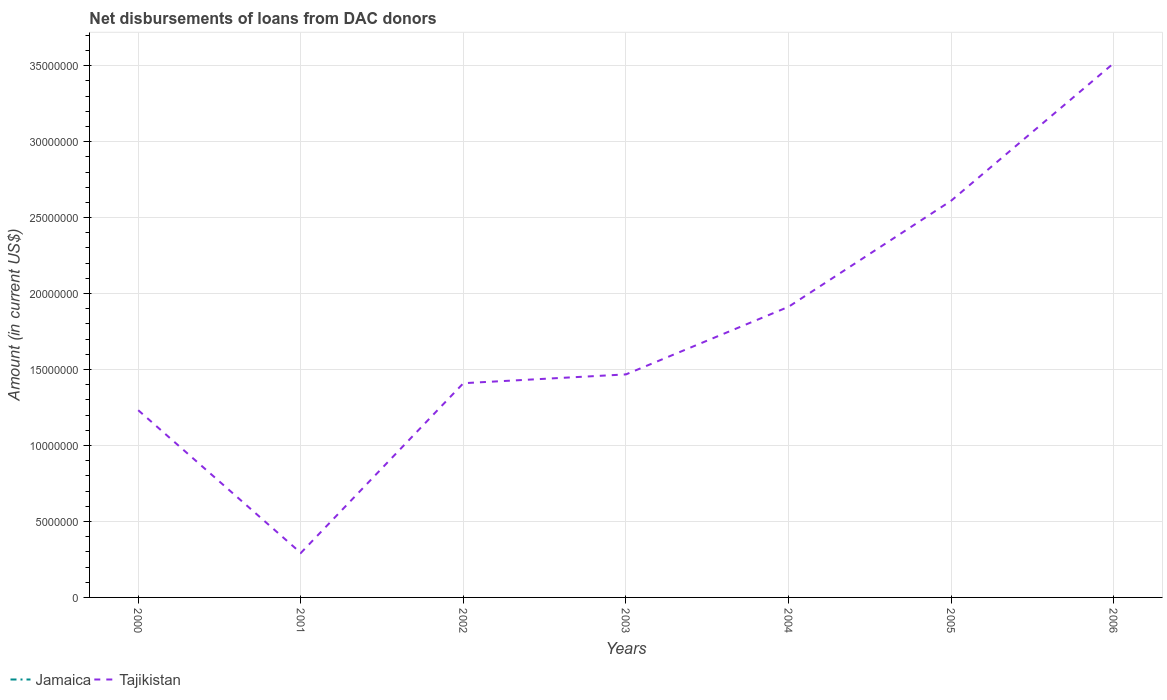How many different coloured lines are there?
Give a very brief answer. 1. Does the line corresponding to Tajikistan intersect with the line corresponding to Jamaica?
Your answer should be very brief. No. Is the number of lines equal to the number of legend labels?
Offer a very short reply. No. Across all years, what is the maximum amount of loans disbursed in Jamaica?
Your response must be concise. 0. What is the total amount of loans disbursed in Tajikistan in the graph?
Keep it short and to the point. -1.20e+07. What is the difference between the highest and the second highest amount of loans disbursed in Tajikistan?
Provide a succinct answer. 3.22e+07. What is the difference between the highest and the lowest amount of loans disbursed in Tajikistan?
Make the answer very short. 3. Is the amount of loans disbursed in Jamaica strictly greater than the amount of loans disbursed in Tajikistan over the years?
Your response must be concise. Yes. What is the difference between two consecutive major ticks on the Y-axis?
Offer a terse response. 5.00e+06. Are the values on the major ticks of Y-axis written in scientific E-notation?
Your answer should be compact. No. Does the graph contain grids?
Make the answer very short. Yes. Where does the legend appear in the graph?
Make the answer very short. Bottom left. How are the legend labels stacked?
Your response must be concise. Horizontal. What is the title of the graph?
Your answer should be very brief. Net disbursements of loans from DAC donors. What is the Amount (in current US$) of Tajikistan in 2000?
Provide a short and direct response. 1.23e+07. What is the Amount (in current US$) of Jamaica in 2001?
Offer a terse response. 0. What is the Amount (in current US$) in Tajikistan in 2001?
Your answer should be very brief. 2.93e+06. What is the Amount (in current US$) in Jamaica in 2002?
Provide a short and direct response. 0. What is the Amount (in current US$) of Tajikistan in 2002?
Your response must be concise. 1.41e+07. What is the Amount (in current US$) in Tajikistan in 2003?
Ensure brevity in your answer.  1.47e+07. What is the Amount (in current US$) of Tajikistan in 2004?
Your response must be concise. 1.91e+07. What is the Amount (in current US$) of Tajikistan in 2005?
Provide a succinct answer. 2.61e+07. What is the Amount (in current US$) in Tajikistan in 2006?
Ensure brevity in your answer.  3.52e+07. Across all years, what is the maximum Amount (in current US$) of Tajikistan?
Ensure brevity in your answer.  3.52e+07. Across all years, what is the minimum Amount (in current US$) of Tajikistan?
Your answer should be very brief. 2.93e+06. What is the total Amount (in current US$) in Jamaica in the graph?
Give a very brief answer. 0. What is the total Amount (in current US$) in Tajikistan in the graph?
Keep it short and to the point. 1.24e+08. What is the difference between the Amount (in current US$) of Tajikistan in 2000 and that in 2001?
Offer a very short reply. 9.40e+06. What is the difference between the Amount (in current US$) in Tajikistan in 2000 and that in 2002?
Offer a terse response. -1.78e+06. What is the difference between the Amount (in current US$) of Tajikistan in 2000 and that in 2003?
Your answer should be very brief. -2.36e+06. What is the difference between the Amount (in current US$) of Tajikistan in 2000 and that in 2004?
Your response must be concise. -6.81e+06. What is the difference between the Amount (in current US$) of Tajikistan in 2000 and that in 2005?
Provide a succinct answer. -1.38e+07. What is the difference between the Amount (in current US$) of Tajikistan in 2000 and that in 2006?
Your response must be concise. -2.28e+07. What is the difference between the Amount (in current US$) of Tajikistan in 2001 and that in 2002?
Your answer should be very brief. -1.12e+07. What is the difference between the Amount (in current US$) of Tajikistan in 2001 and that in 2003?
Offer a terse response. -1.18e+07. What is the difference between the Amount (in current US$) in Tajikistan in 2001 and that in 2004?
Offer a very short reply. -1.62e+07. What is the difference between the Amount (in current US$) in Tajikistan in 2001 and that in 2005?
Ensure brevity in your answer.  -2.32e+07. What is the difference between the Amount (in current US$) in Tajikistan in 2001 and that in 2006?
Make the answer very short. -3.22e+07. What is the difference between the Amount (in current US$) in Tajikistan in 2002 and that in 2003?
Make the answer very short. -5.79e+05. What is the difference between the Amount (in current US$) of Tajikistan in 2002 and that in 2004?
Provide a succinct answer. -5.03e+06. What is the difference between the Amount (in current US$) of Tajikistan in 2002 and that in 2005?
Make the answer very short. -1.20e+07. What is the difference between the Amount (in current US$) of Tajikistan in 2002 and that in 2006?
Keep it short and to the point. -2.11e+07. What is the difference between the Amount (in current US$) in Tajikistan in 2003 and that in 2004?
Ensure brevity in your answer.  -4.45e+06. What is the difference between the Amount (in current US$) of Tajikistan in 2003 and that in 2005?
Your answer should be very brief. -1.14e+07. What is the difference between the Amount (in current US$) of Tajikistan in 2003 and that in 2006?
Your response must be concise. -2.05e+07. What is the difference between the Amount (in current US$) of Tajikistan in 2004 and that in 2005?
Offer a terse response. -6.98e+06. What is the difference between the Amount (in current US$) of Tajikistan in 2004 and that in 2006?
Your answer should be very brief. -1.60e+07. What is the difference between the Amount (in current US$) of Tajikistan in 2005 and that in 2006?
Provide a succinct answer. -9.06e+06. What is the average Amount (in current US$) of Jamaica per year?
Ensure brevity in your answer.  0. What is the average Amount (in current US$) of Tajikistan per year?
Your answer should be compact. 1.78e+07. What is the ratio of the Amount (in current US$) in Tajikistan in 2000 to that in 2001?
Ensure brevity in your answer.  4.21. What is the ratio of the Amount (in current US$) of Tajikistan in 2000 to that in 2002?
Your response must be concise. 0.87. What is the ratio of the Amount (in current US$) in Tajikistan in 2000 to that in 2003?
Your response must be concise. 0.84. What is the ratio of the Amount (in current US$) of Tajikistan in 2000 to that in 2004?
Provide a short and direct response. 0.64. What is the ratio of the Amount (in current US$) of Tajikistan in 2000 to that in 2005?
Your response must be concise. 0.47. What is the ratio of the Amount (in current US$) of Tajikistan in 2000 to that in 2006?
Keep it short and to the point. 0.35. What is the ratio of the Amount (in current US$) in Tajikistan in 2001 to that in 2002?
Your response must be concise. 0.21. What is the ratio of the Amount (in current US$) of Tajikistan in 2001 to that in 2003?
Offer a very short reply. 0.2. What is the ratio of the Amount (in current US$) of Tajikistan in 2001 to that in 2004?
Provide a succinct answer. 0.15. What is the ratio of the Amount (in current US$) in Tajikistan in 2001 to that in 2005?
Give a very brief answer. 0.11. What is the ratio of the Amount (in current US$) of Tajikistan in 2001 to that in 2006?
Provide a short and direct response. 0.08. What is the ratio of the Amount (in current US$) in Tajikistan in 2002 to that in 2003?
Ensure brevity in your answer.  0.96. What is the ratio of the Amount (in current US$) in Tajikistan in 2002 to that in 2004?
Your answer should be very brief. 0.74. What is the ratio of the Amount (in current US$) in Tajikistan in 2002 to that in 2005?
Ensure brevity in your answer.  0.54. What is the ratio of the Amount (in current US$) of Tajikistan in 2002 to that in 2006?
Give a very brief answer. 0.4. What is the ratio of the Amount (in current US$) in Tajikistan in 2003 to that in 2004?
Give a very brief answer. 0.77. What is the ratio of the Amount (in current US$) in Tajikistan in 2003 to that in 2005?
Provide a short and direct response. 0.56. What is the ratio of the Amount (in current US$) of Tajikistan in 2003 to that in 2006?
Keep it short and to the point. 0.42. What is the ratio of the Amount (in current US$) of Tajikistan in 2004 to that in 2005?
Ensure brevity in your answer.  0.73. What is the ratio of the Amount (in current US$) of Tajikistan in 2004 to that in 2006?
Make the answer very short. 0.54. What is the ratio of the Amount (in current US$) in Tajikistan in 2005 to that in 2006?
Provide a short and direct response. 0.74. What is the difference between the highest and the second highest Amount (in current US$) of Tajikistan?
Your response must be concise. 9.06e+06. What is the difference between the highest and the lowest Amount (in current US$) in Tajikistan?
Provide a short and direct response. 3.22e+07. 